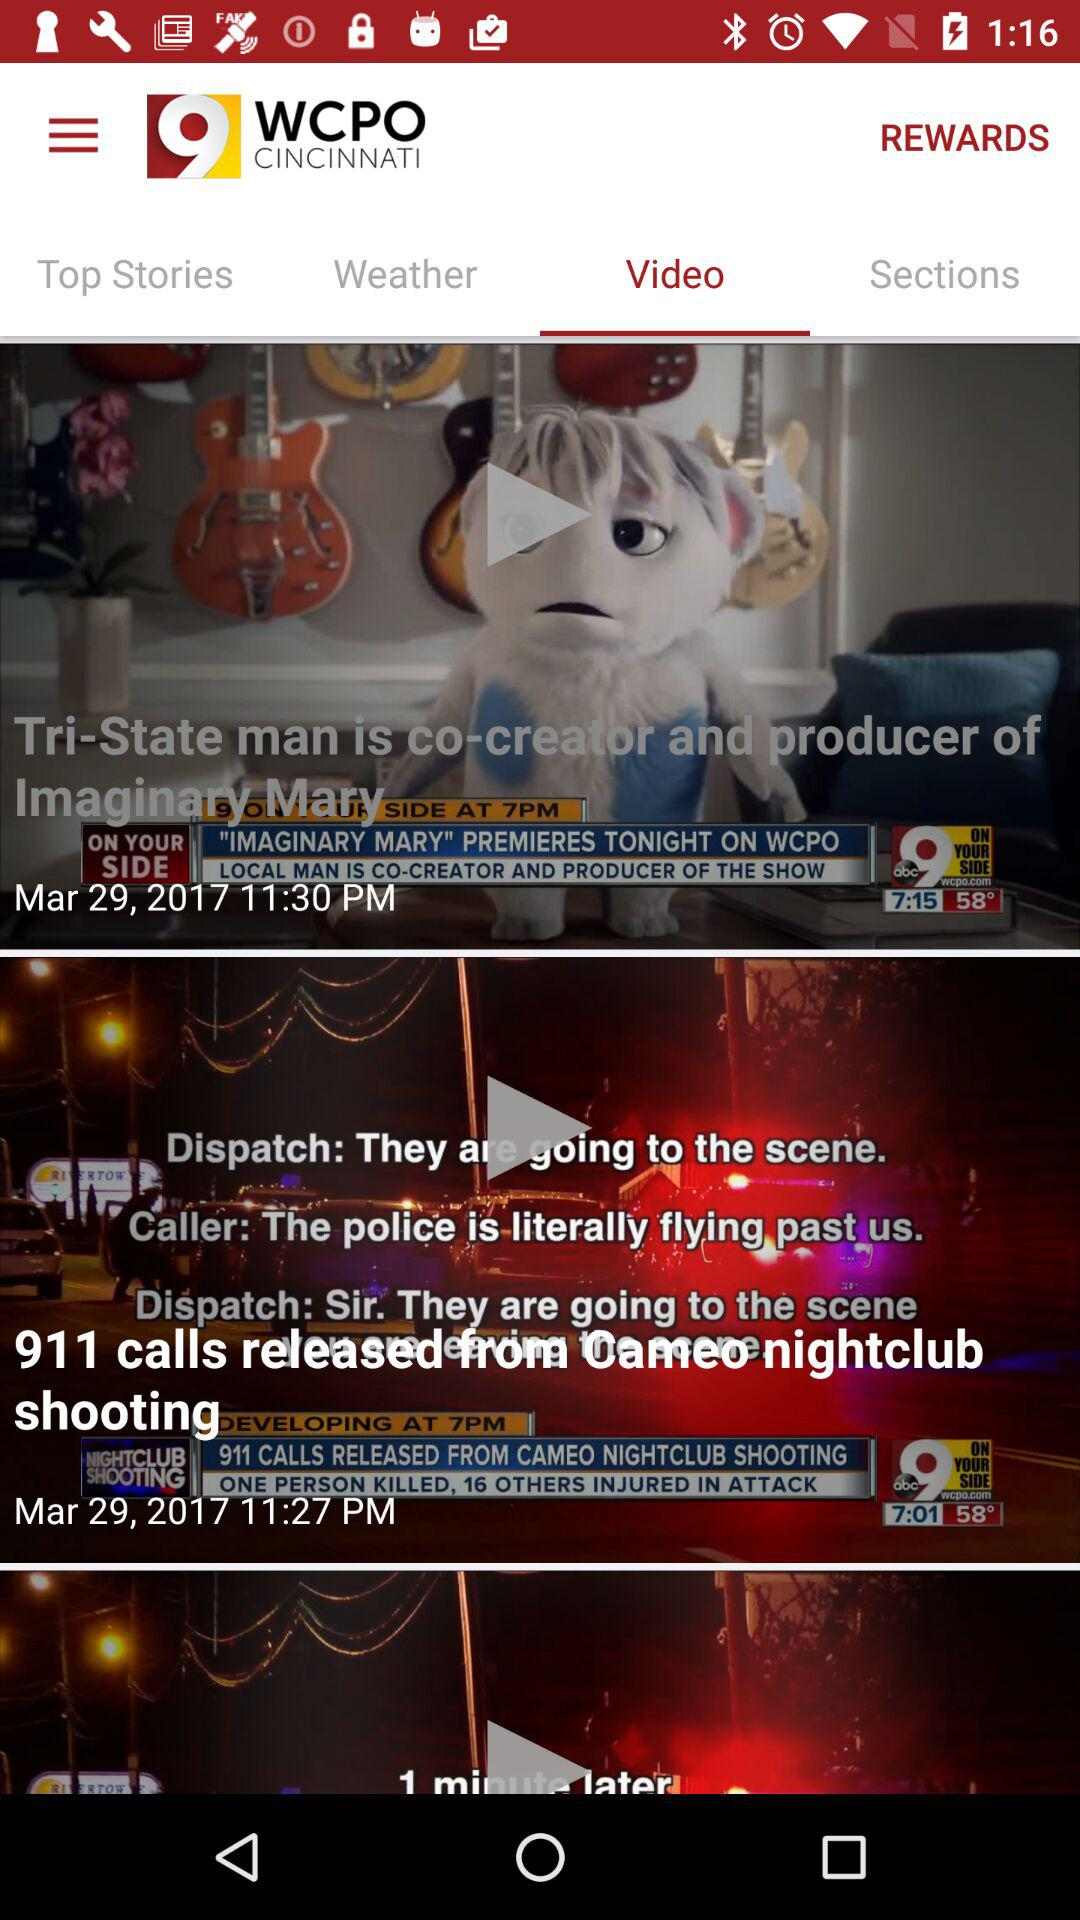What is the channel name where the video is uploaded? The channel name is "WCPO 9 CINCINNATI". 